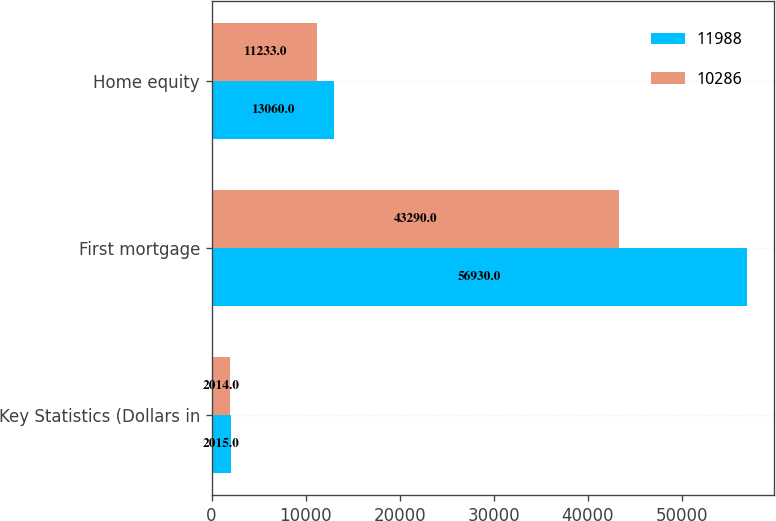<chart> <loc_0><loc_0><loc_500><loc_500><stacked_bar_chart><ecel><fcel>Key Statistics (Dollars in<fcel>First mortgage<fcel>Home equity<nl><fcel>11988<fcel>2015<fcel>56930<fcel>13060<nl><fcel>10286<fcel>2014<fcel>43290<fcel>11233<nl></chart> 